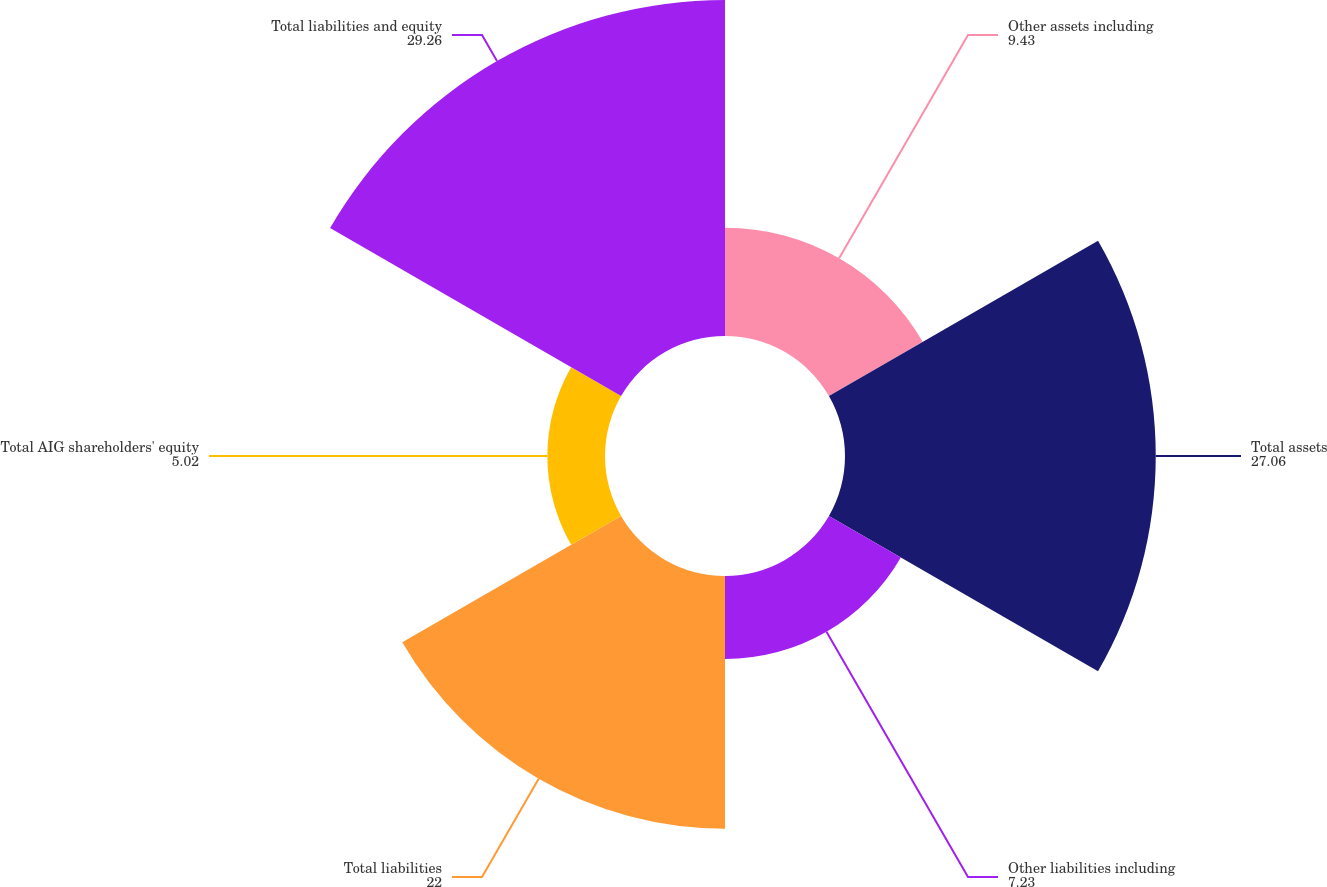Convert chart to OTSL. <chart><loc_0><loc_0><loc_500><loc_500><pie_chart><fcel>Other assets including<fcel>Total assets<fcel>Other liabilities including<fcel>Total liabilities<fcel>Total AIG shareholders' equity<fcel>Total liabilities and equity<nl><fcel>9.43%<fcel>27.06%<fcel>7.23%<fcel>22.0%<fcel>5.02%<fcel>29.26%<nl></chart> 